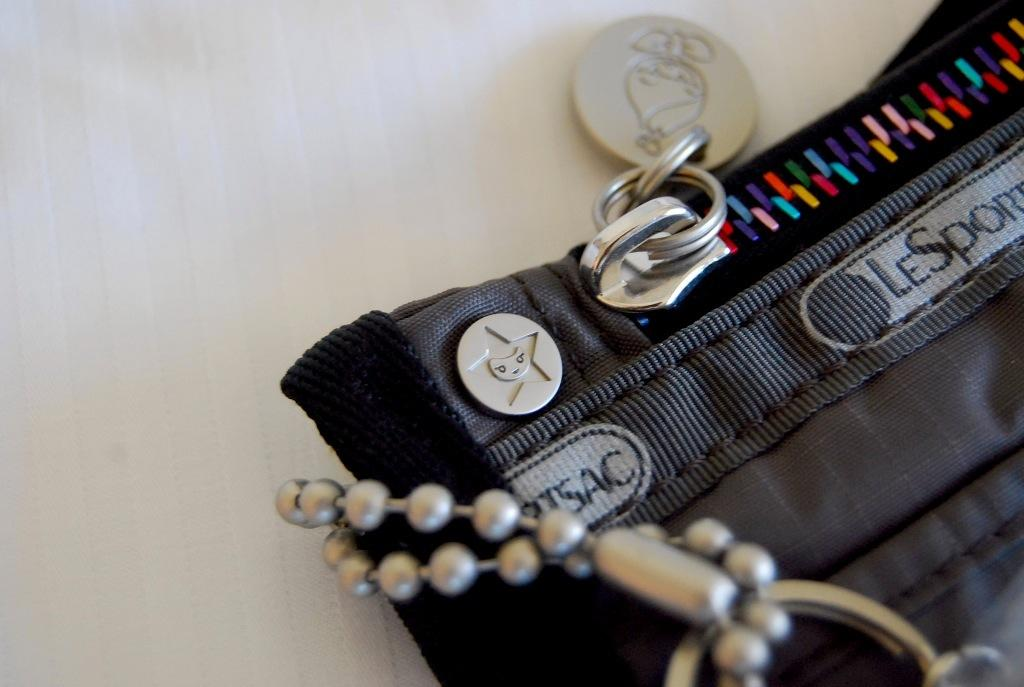What is the color of the pouch in the image? The pouch is black in color. Does the pouch have any closure mechanism? Yes, the pouch has a zip. What is the color of the surface on which the pouch is placed? The pouch is on a white color surface. What type of guitar is being played by the band in the image? There is no guitar or band present in the image; it only features a black color pouch on a white color surface. 